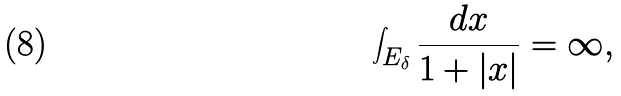Convert formula to latex. <formula><loc_0><loc_0><loc_500><loc_500>\int _ { E _ { \delta } } \frac { d x } { 1 + | x | } = \infty ,</formula> 